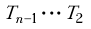Convert formula to latex. <formula><loc_0><loc_0><loc_500><loc_500>T _ { n - 1 } \cdot \cdot \cdot T _ { 2 }</formula> 